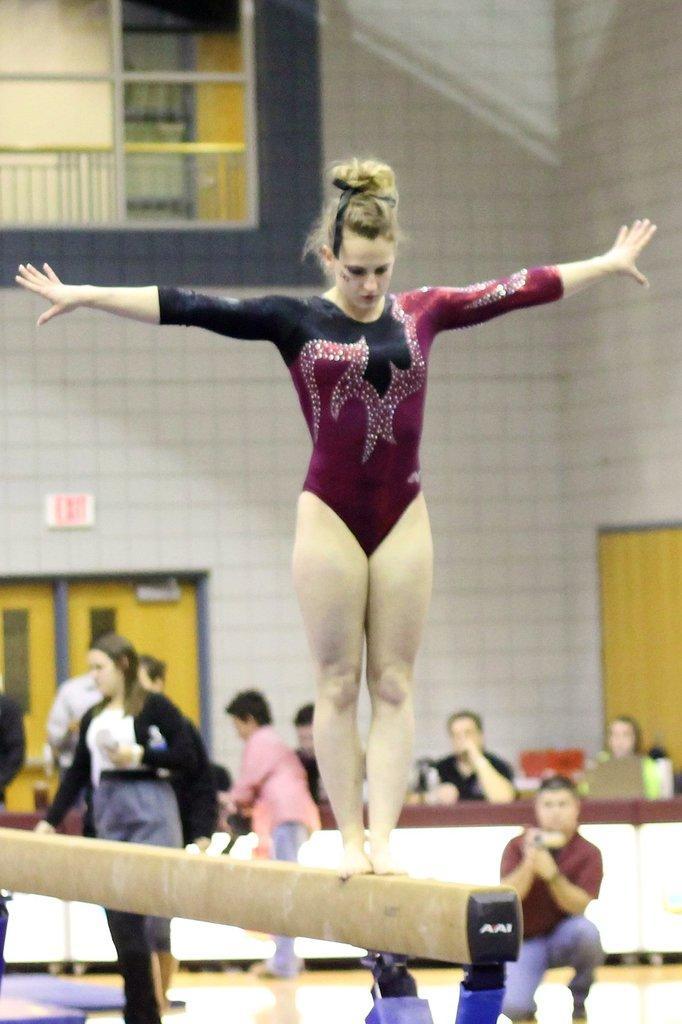Describe this image in one or two sentences. In this image I can see a woman wearing maroon and black colored dress is standing on the pole which is cream in color. In the background I can see a person is sitting and holding a camera , few other persons standing, few persons sitting on chairs, the wall, the door and the window. 